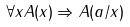Convert formula to latex. <formula><loc_0><loc_0><loc_500><loc_500>\forall x A ( x ) \Rightarrow A ( a / x )</formula> 